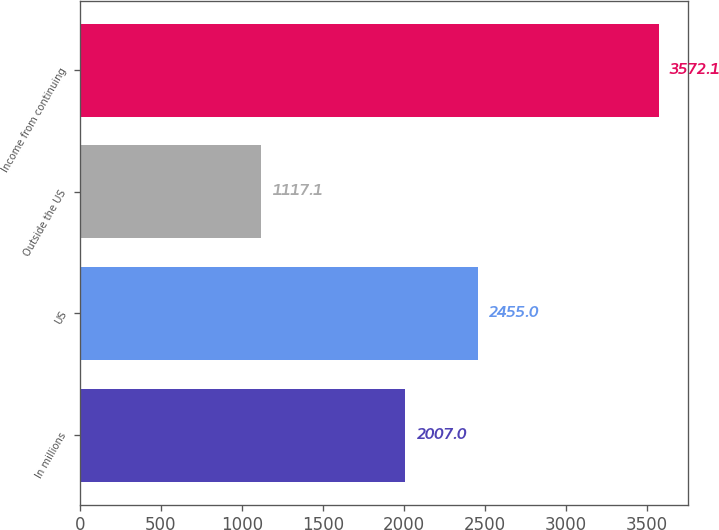Convert chart to OTSL. <chart><loc_0><loc_0><loc_500><loc_500><bar_chart><fcel>In millions<fcel>US<fcel>Outside the US<fcel>Income from continuing<nl><fcel>2007<fcel>2455<fcel>1117.1<fcel>3572.1<nl></chart> 